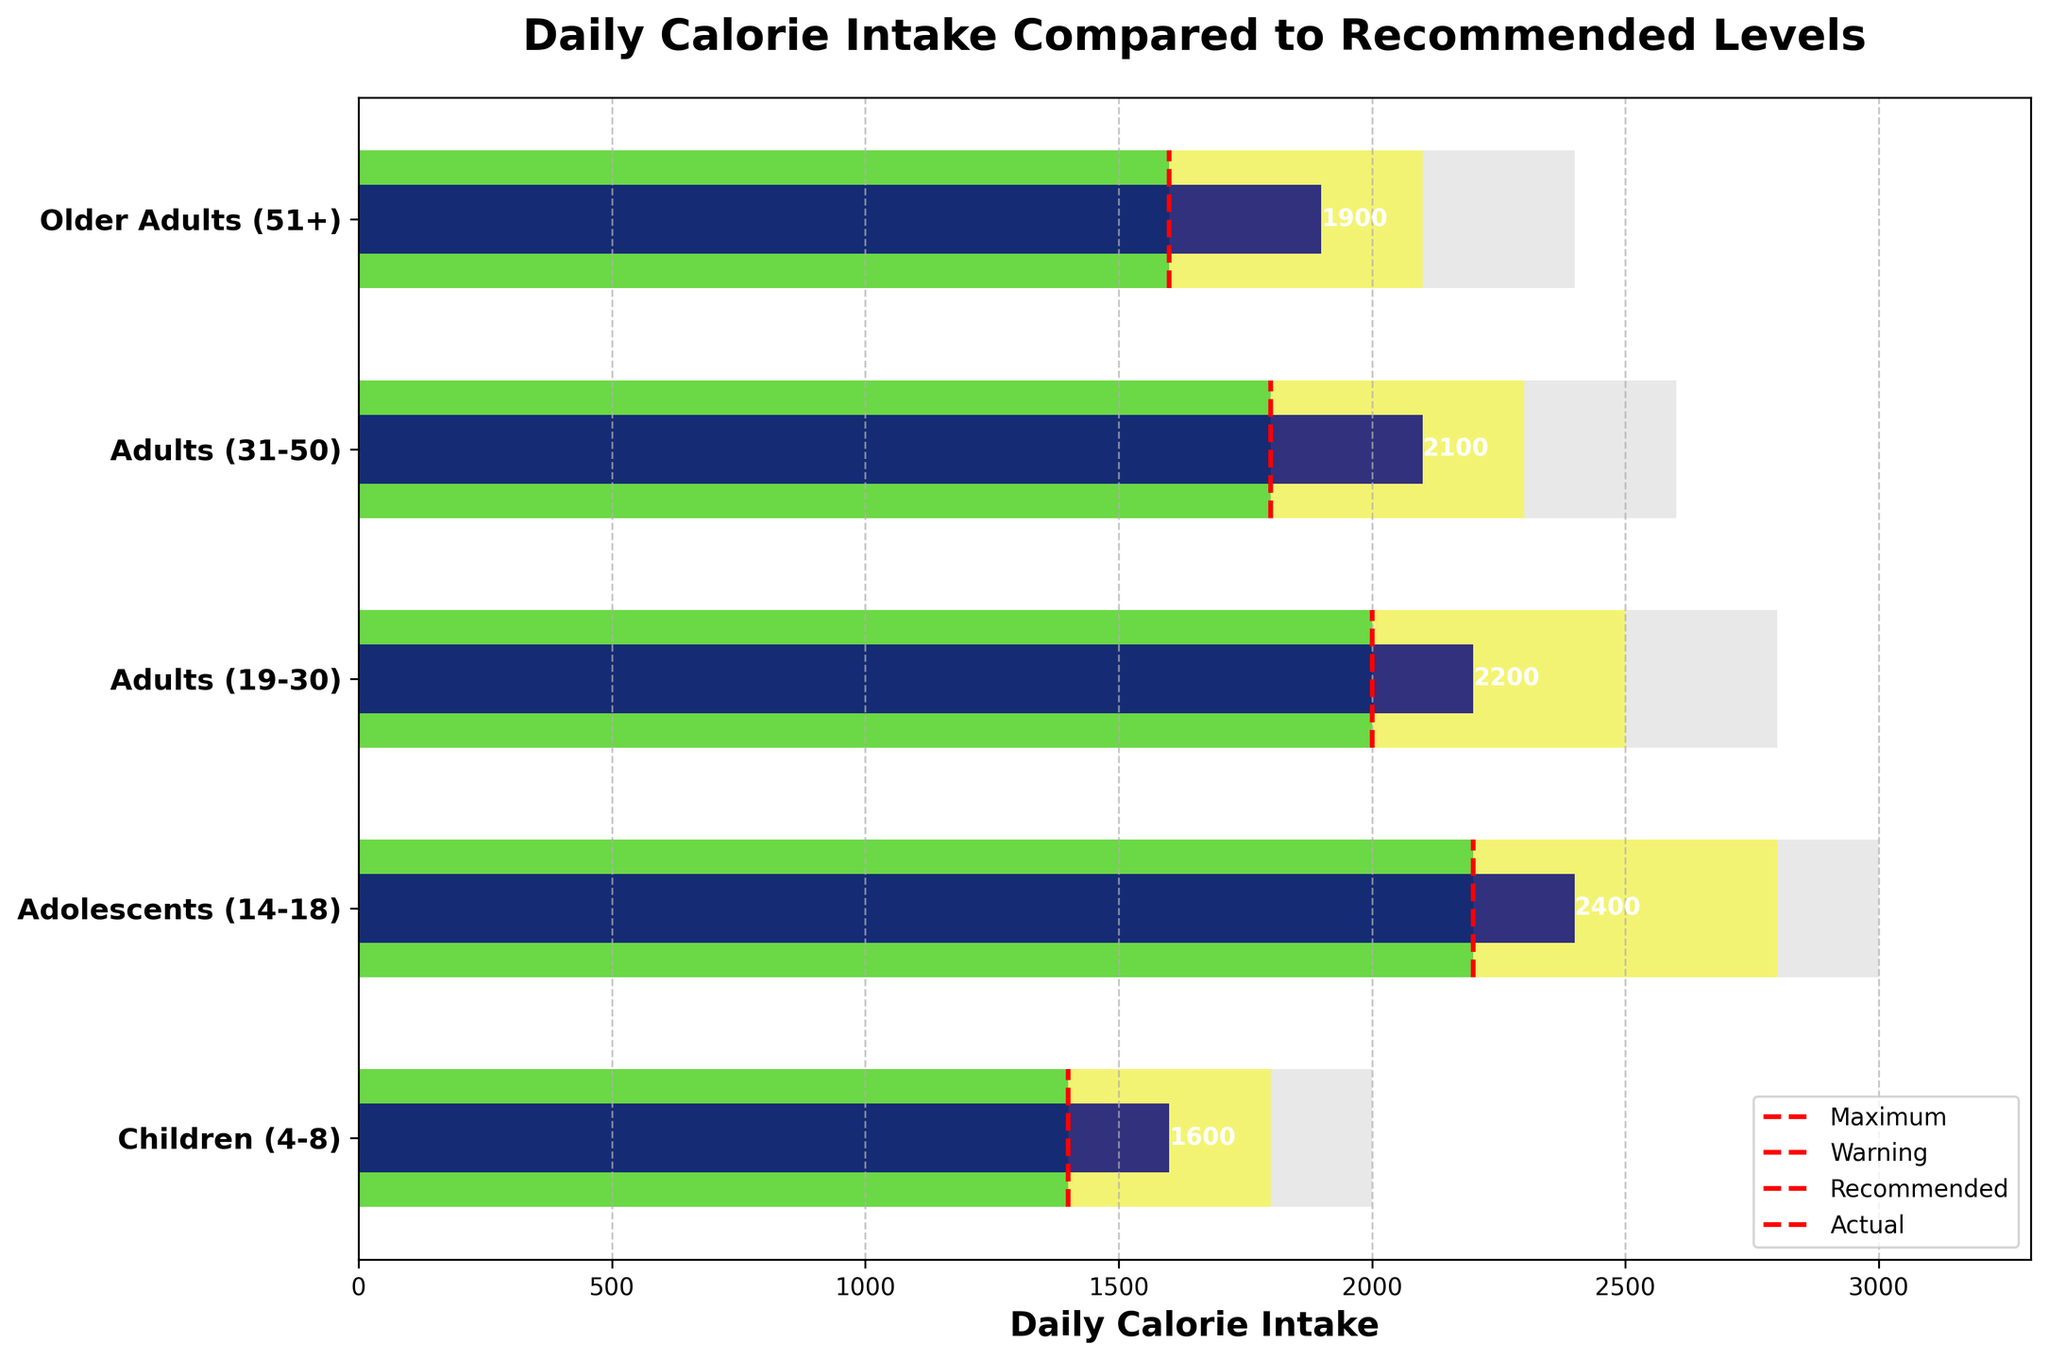What is the title of the chart? The title is usually displayed at the top of the chart and provides a summary of its content.
Answer: Daily Calorie Intake Compared to Recommended Levels Which age group has the highest actual calorie intake? By scanning through the "Actual Intake" bars for each age group, we can identify the tallest one.
Answer: Adolescents (14-18) What are the four categories of calorie bars shown in the chart? Recognizing the different colors and their corresponding labels in the legend, we can determine the categories.
Answer: Maximum, Warning, Recommended, Actual How many age groups have actual intake surpassing the recommended intake? Compare the height of the "Actual Intake" bars with the "Recommended Intake" bars for each age group.
Answer: All age groups Which age group has the smallest difference between actual intake and recommended intake? Subtract the "Recommended Intake" from the "Actual Intake" for each age group and compare the differences.
Answer: Adults (19-30) How does the actual intake of Older Adults (51+) compare to their recommended intake? Compare the height of the "Actual Intake" bar to the "Recommended Intake" bar for Older Adults (51+).
Answer: It is higher What is the visual indication used to show the recommended intake for each age group? Identify the visual element that consistently marks the recommended intake across all age groups.
Answer: Red dashed vertical lines Which age group has the highest warning level of calorie intake? Look at the "Warning Level" bars to find the tallest one.
Answer: Adolescents (14-18) What is the range of calorie intake considered for adults (31-50) before reaching the warning level? The difference between the "Warning Level" and the "Recommended Intake" for the Adults (31-50).
Answer: 500 calories How does the maximum level for Children's (4-8) intake compare to the adults' (19-30) maximum level? Compare the height of the "Maximum Level" bar for Children (4-8) to the Adults (19-30).
Answer: It's lower 